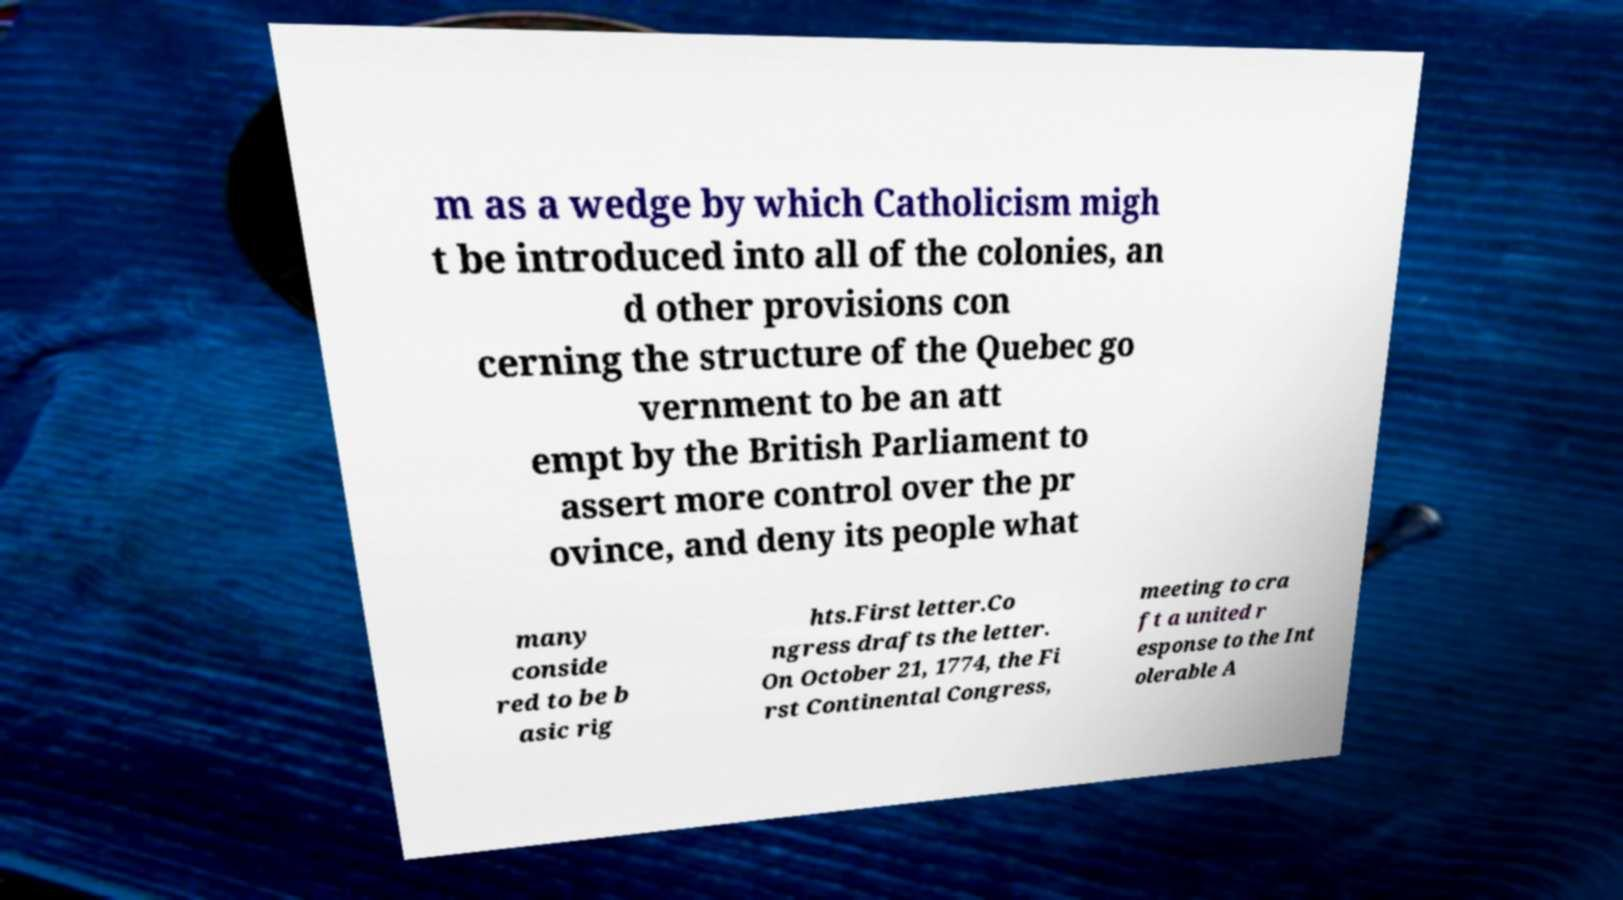I need the written content from this picture converted into text. Can you do that? m as a wedge by which Catholicism migh t be introduced into all of the colonies, an d other provisions con cerning the structure of the Quebec go vernment to be an att empt by the British Parliament to assert more control over the pr ovince, and deny its people what many conside red to be b asic rig hts.First letter.Co ngress drafts the letter. On October 21, 1774, the Fi rst Continental Congress, meeting to cra ft a united r esponse to the Int olerable A 